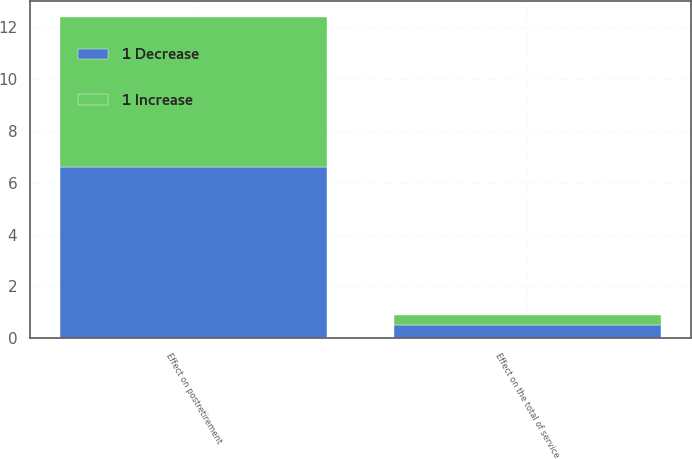Convert chart. <chart><loc_0><loc_0><loc_500><loc_500><stacked_bar_chart><ecel><fcel>Effect on the total of service<fcel>Effect on postretirement<nl><fcel>1 Decrease<fcel>0.5<fcel>6.6<nl><fcel>1 Increase<fcel>0.4<fcel>5.8<nl></chart> 